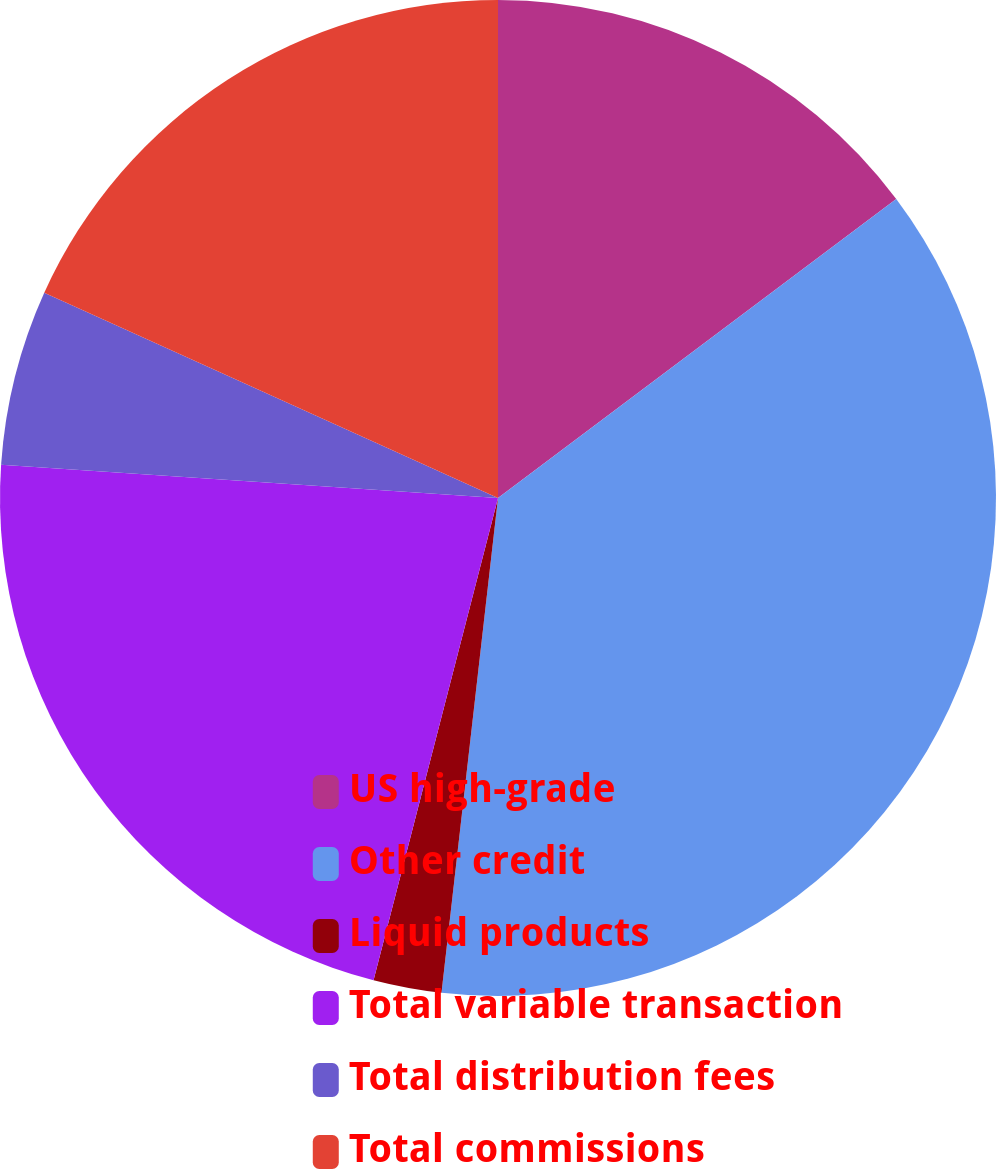<chart> <loc_0><loc_0><loc_500><loc_500><pie_chart><fcel>US high-grade<fcel>Other credit<fcel>Liquid products<fcel>Total variable transaction<fcel>Total distribution fees<fcel>Total commissions<nl><fcel>14.75%<fcel>37.06%<fcel>2.21%<fcel>22.04%<fcel>5.7%<fcel>18.24%<nl></chart> 